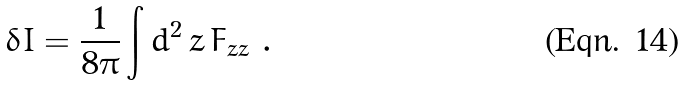<formula> <loc_0><loc_0><loc_500><loc_500>\delta I = \frac { 1 } { 8 \pi } \int d ^ { 2 } \, z \, F _ { z { \bar { z } } } \ .</formula> 